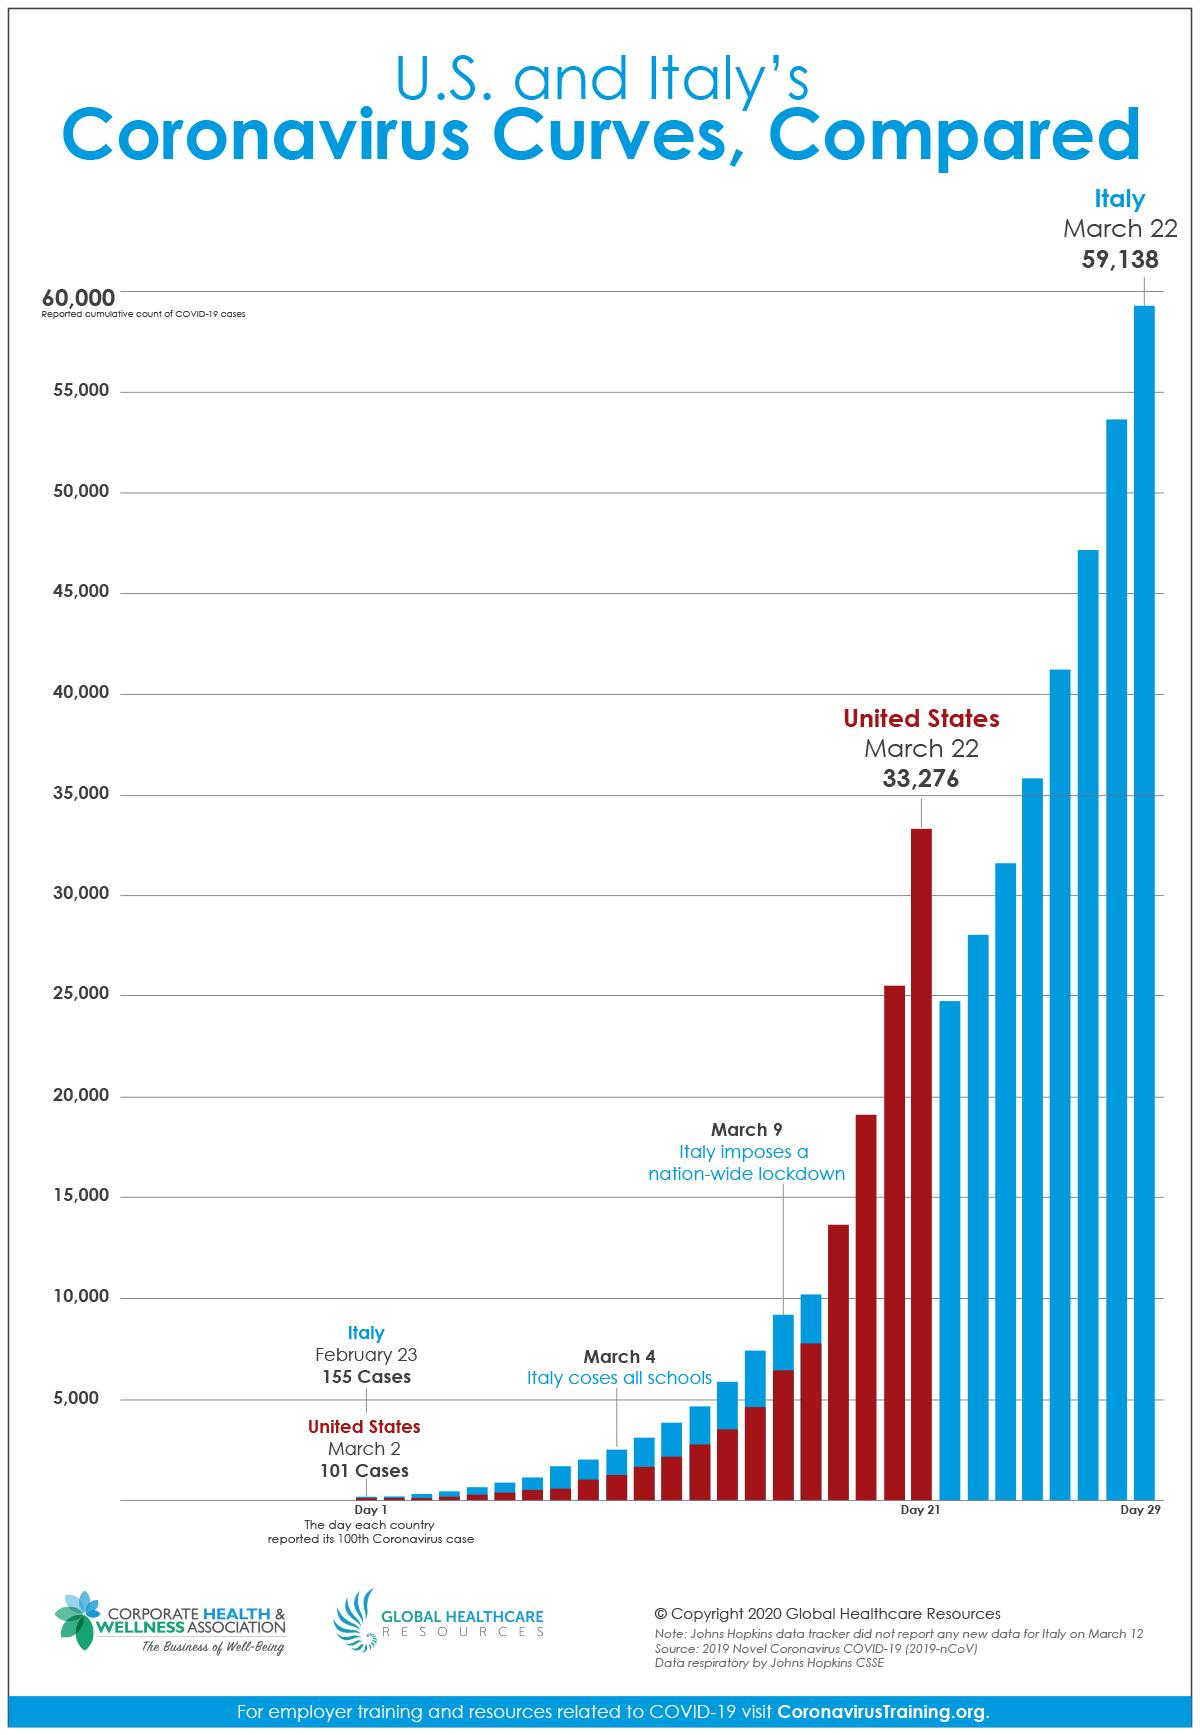Point out several critical features in this image. On March 22, there were 59,138 cases in Italy. On March 22, there were 33,276 cases in the United States. On February 23, Italy surpassed 100 cases. On March 2, the number of cases in the United States exceeded 100. On March 4th, schools in Italy officially closed. 